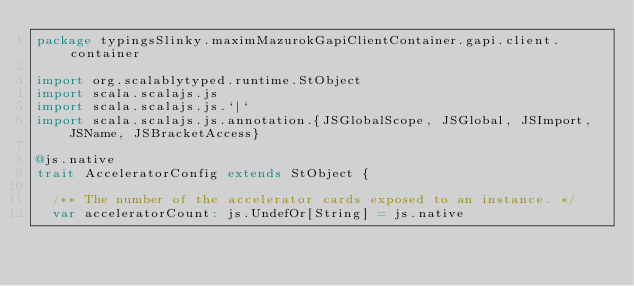<code> <loc_0><loc_0><loc_500><loc_500><_Scala_>package typingsSlinky.maximMazurokGapiClientContainer.gapi.client.container

import org.scalablytyped.runtime.StObject
import scala.scalajs.js
import scala.scalajs.js.`|`
import scala.scalajs.js.annotation.{JSGlobalScope, JSGlobal, JSImport, JSName, JSBracketAccess}

@js.native
trait AcceleratorConfig extends StObject {
  
  /** The number of the accelerator cards exposed to an instance. */
  var acceleratorCount: js.UndefOr[String] = js.native
  </code> 